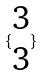<formula> <loc_0><loc_0><loc_500><loc_500>\{ \begin{matrix} 3 \\ 3 \end{matrix} \}</formula> 